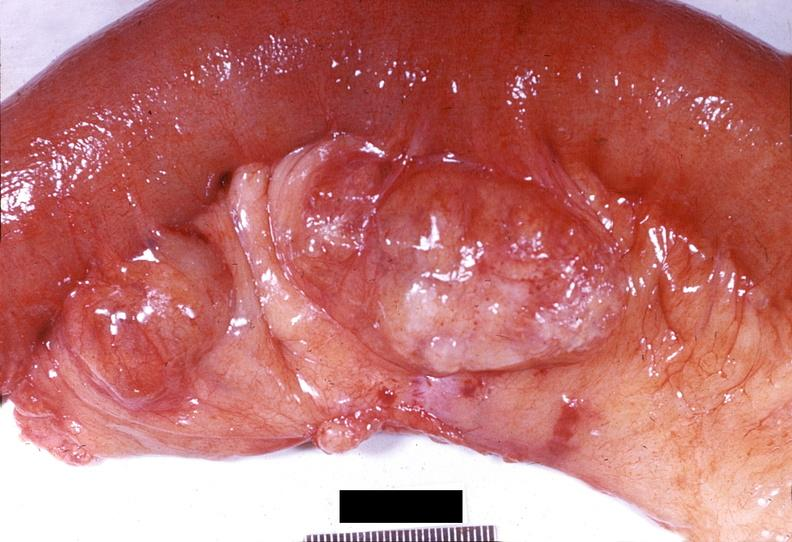does this image show gejunum, diverticula?
Answer the question using a single word or phrase. Yes 